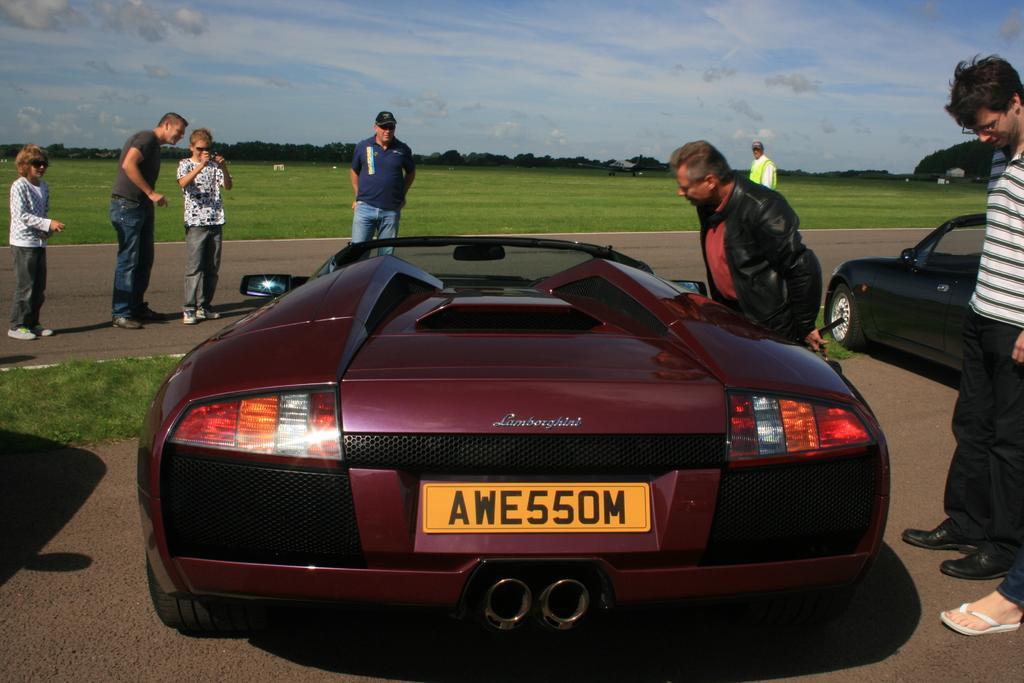Can you describe this image briefly? In this picture there are vehicles on the road and there is a text and there is a number plate on the car. There are group of people standing and there is a person with white t-shirt is standing and holding the device. At the back there are trees. At the top there is sky and there are clouds. At the bottom there is grass and there is a road. 